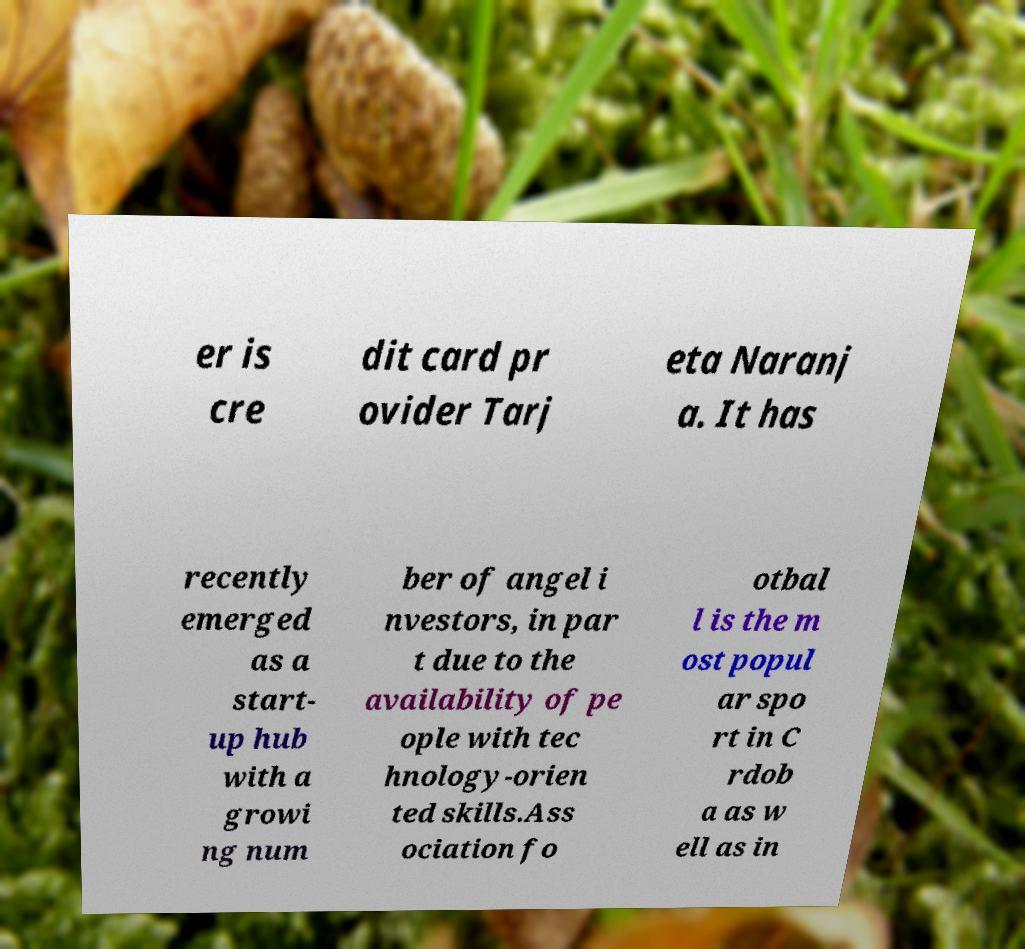I need the written content from this picture converted into text. Can you do that? er is cre dit card pr ovider Tarj eta Naranj a. It has recently emerged as a start- up hub with a growi ng num ber of angel i nvestors, in par t due to the availability of pe ople with tec hnology-orien ted skills.Ass ociation fo otbal l is the m ost popul ar spo rt in C rdob a as w ell as in 